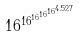<formula> <loc_0><loc_0><loc_500><loc_500>1 6 ^ { 1 6 ^ { 1 6 ^ { 1 6 ^ { 1 6 ^ { 4 . 5 2 7 } } } } }</formula> 